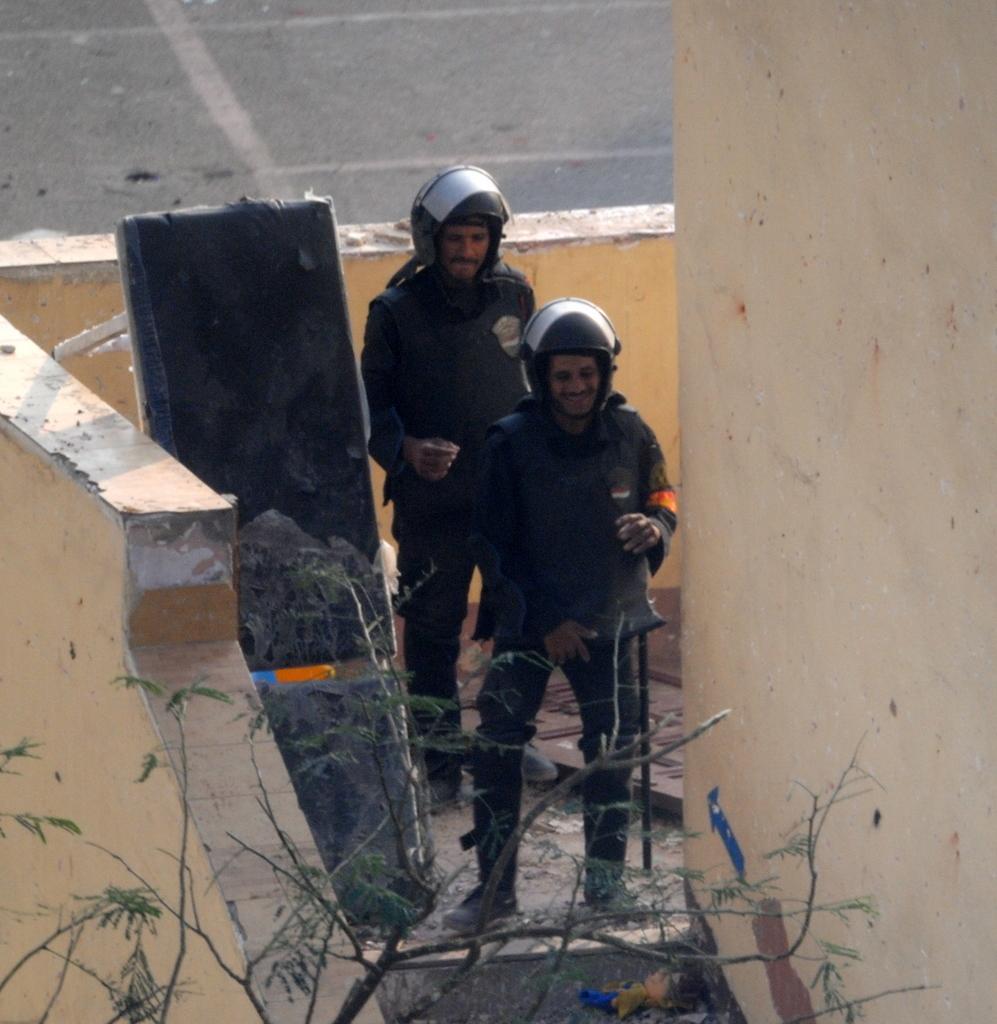How would you summarize this image in a sentence or two? In this picture we can observe two men wearing helmets on their heads. We can observe a black color bench beside them. There is a tree. We can observe cream color wall. In the background there is a road. 